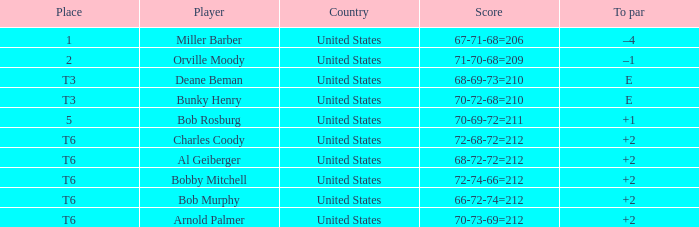What is the top score of player bunky henry? E. 